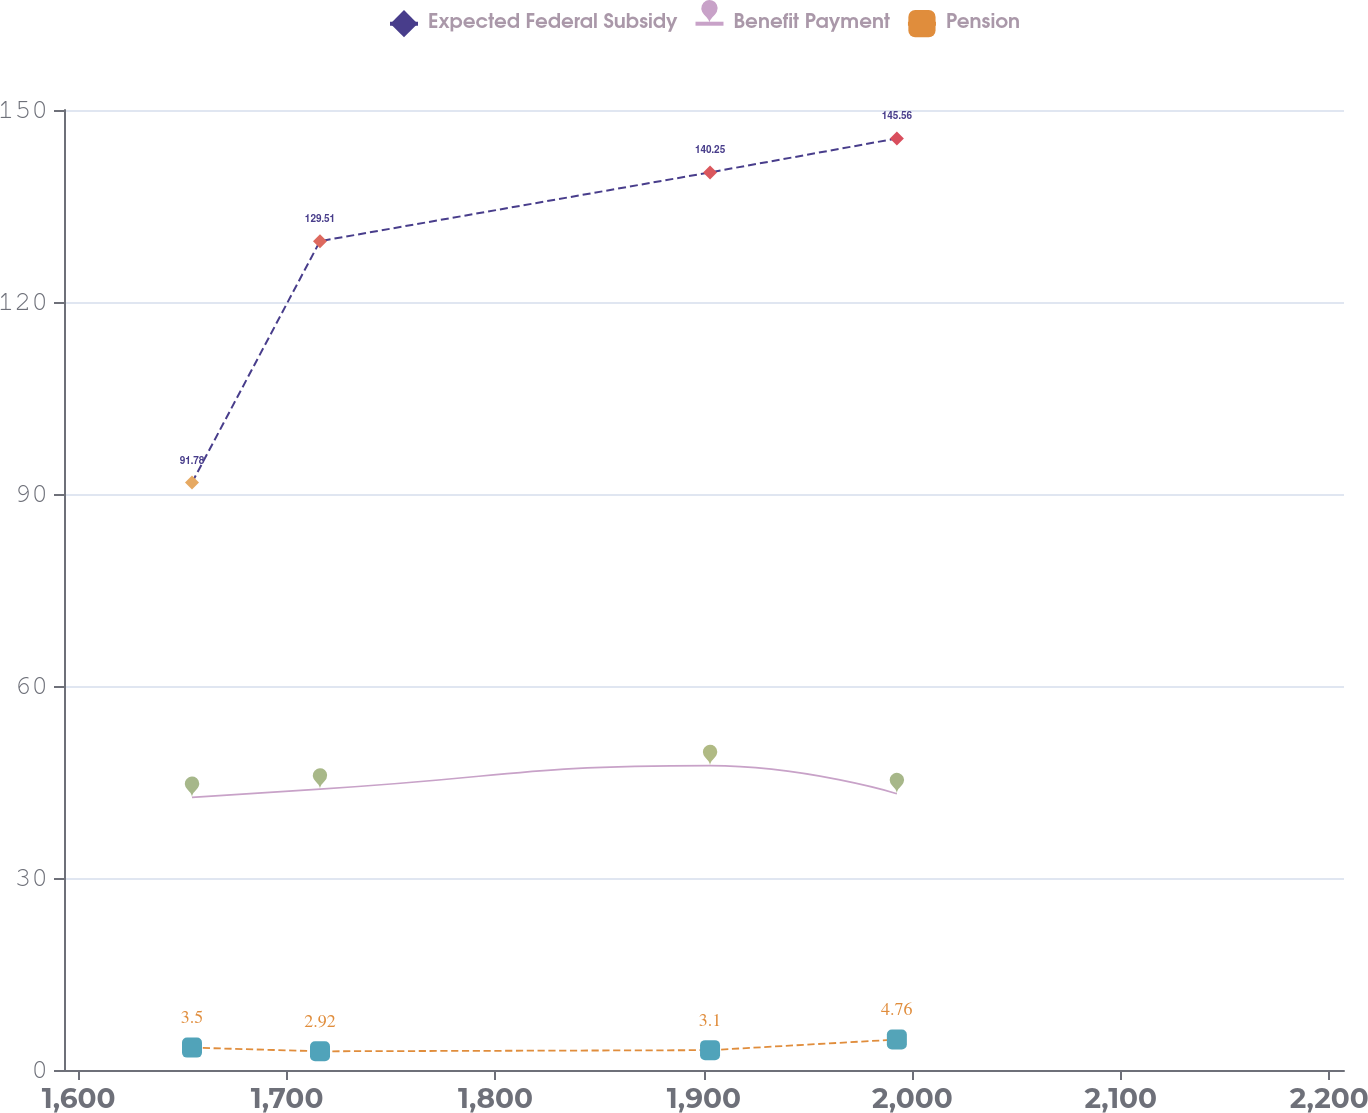<chart> <loc_0><loc_0><loc_500><loc_500><line_chart><ecel><fcel>Expected Federal Subsidy<fcel>Benefit Payment<fcel>Pension<nl><fcel>1654.4<fcel>91.78<fcel>42.6<fcel>3.5<nl><fcel>1715.81<fcel>129.51<fcel>43.89<fcel>2.92<nl><fcel>1902.94<fcel>140.25<fcel>47.56<fcel>3.1<nl><fcel>1992.57<fcel>145.56<fcel>43.18<fcel>4.76<nl><fcel>2268.5<fcel>134.82<fcel>48.42<fcel>4.58<nl></chart> 